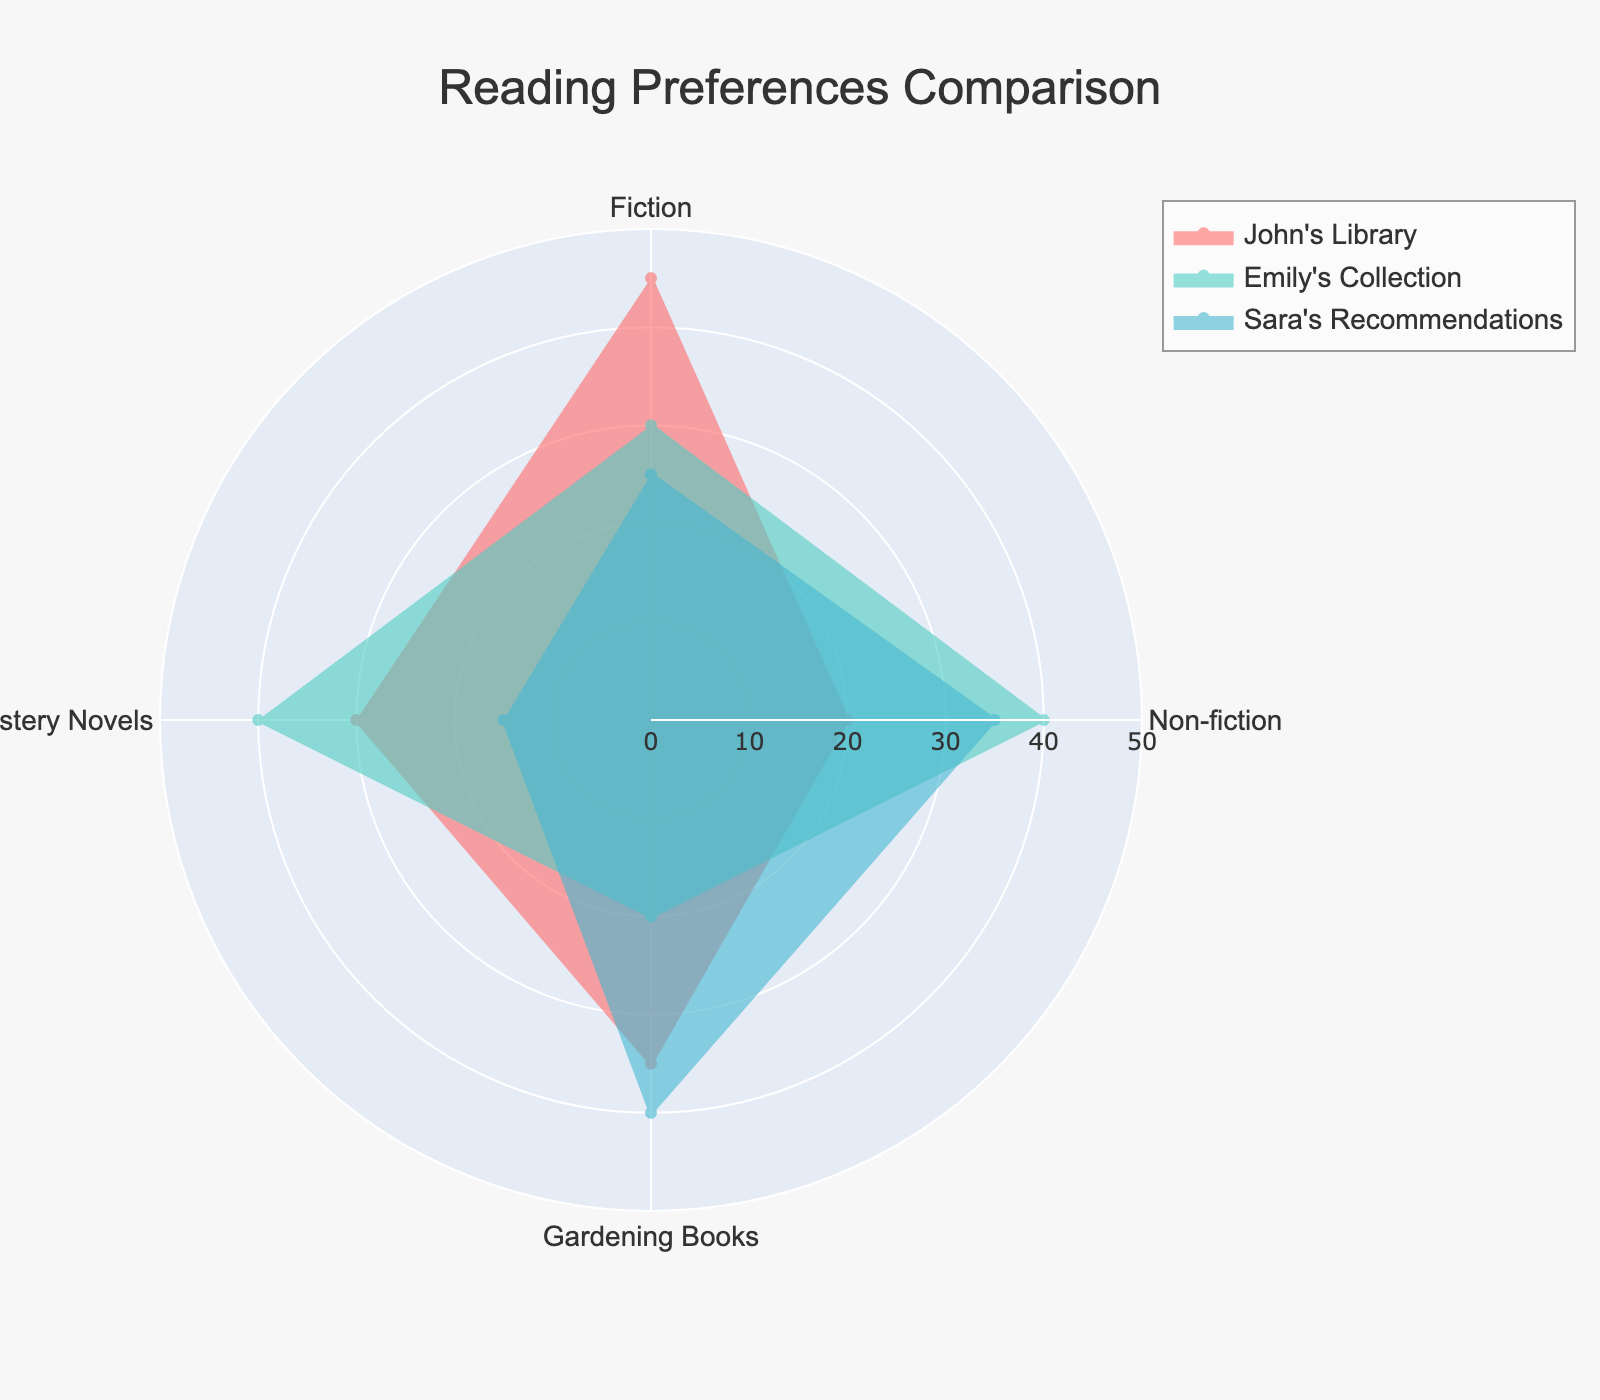what categories have the highest and lowest values in Emily's Collection? First, locate Emily's Collection on the radar chart. Identify the highest value, which is for Non-fiction at 40. Then, identify the lowest value, which is for Gardening Books at 20.
Answer: highest: Non-fiction, lowest: Gardening Books What's the average value of Sara's Recommendations? There are 4 categories: Fiction (25), Non-fiction (35), Gardening Books (40), Mystery Novels (15). Sum is 115. Average = 115/4 = 28.75
Answer: 28.75 Which collection has the highest value for Gardening Books? Check the values for Gardening Books in each collection: John's Library (35), Emily's Collection (20), Sara's Recommendations (40). The highest value is 40 in Sara's Recommendations.
Answer: Sara's Recommendations How does John's Library compare to Emily's Collection in terms of Fiction? John's Library has a value of 45 for Fiction, while Emily's Collection has a value of 30 for Fiction. Therefore, John's Library has a higher value for Fiction.
Answer: John's Library has a higher value What is the difference in Mystery Novels between John's Library and Sara's Recommendations? John's Library has 30 for Mystery Novels, and Sara's Recommendations has 15. The difference is 30 - 15 = 15.
Answer: 15 List the categories where Sara's Recommendations have a higher value than Emily's Collection. Compare values category by category: 
Fiction: Sara (25) < Emily (30)
Non-fiction: Sara (35) < Emily (40)
Gardening Books: Sara (40) > Emily (20)
Mystery Novels: Sara (15) < Emily (40)
Sara’s Recommendations is higher only for Gardening Books.
Answer: Gardening Books What is the sum of values for Gardening Books across all collections? Sum the Gardening Books values: John's Library (35), Emily's Collection (20), Sara's Recommendations (40). The total sum is 35 + 20 + 40 = 95.
Answer: 95 Which category shows the most balanced values across all collections? By inspecting each category's values: 
- Fiction: John's (45), Emily's (30), Sara's (25)
- Non-fiction: John's (20), Emily's (40), Sara's (35)
- Gardening Books: John's (35), Emily's (20), Sara's (40)
- Mystery Novels: John's (30), Emily's (40), Sara's (15)
Gardening Books shows the most balance if we consider that no value is too extreme compared to others.
Answer: Gardening Books Which collection has the most diverse reading preferences based on the range of values? Calculate the range (max - min) for each collection:
John's Library: 45 - 20 = 25
Emily's Collection: 40 - 20 = 20
Sara's Recommendations: 40 - 15 = 25
John's Library and Sara's Recommendations both have the most diverse preferences with a range of 25.
Answer: John's Library, Sara's Recommendations 